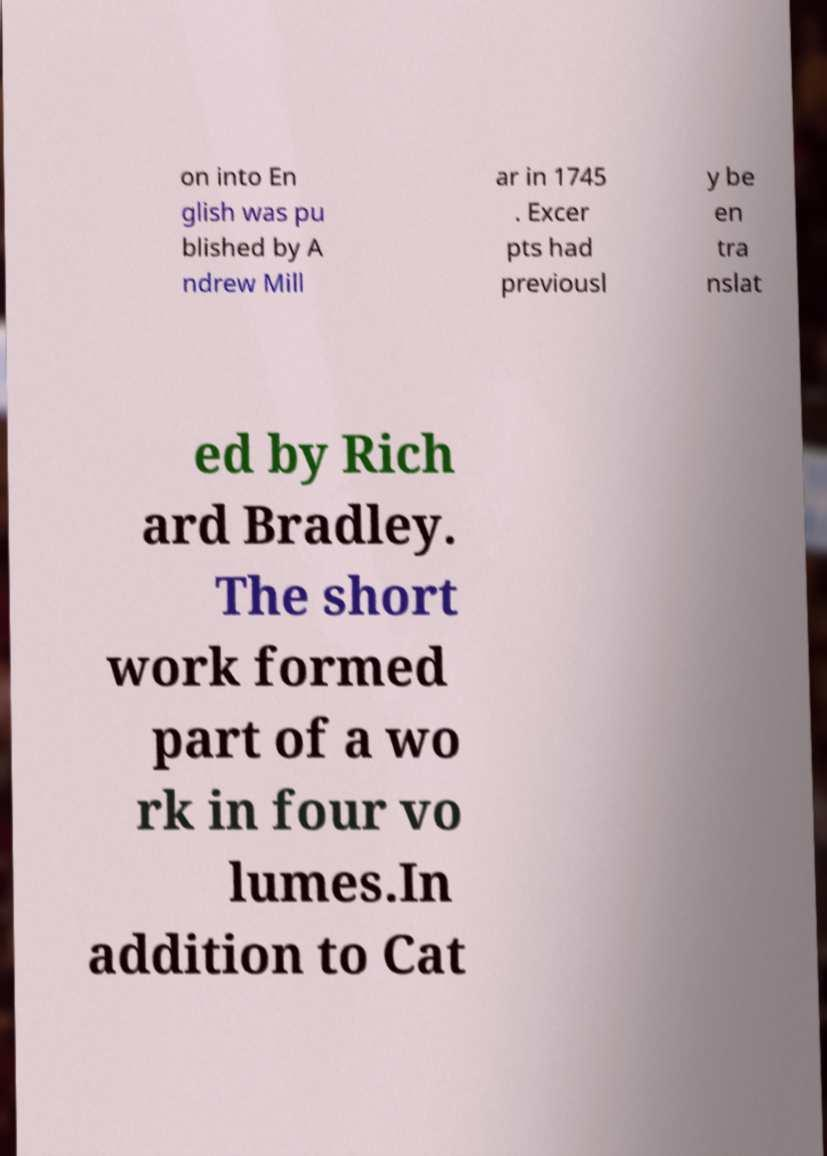What messages or text are displayed in this image? I need them in a readable, typed format. on into En glish was pu blished by A ndrew Mill ar in 1745 . Excer pts had previousl y be en tra nslat ed by Rich ard Bradley. The short work formed part of a wo rk in four vo lumes.In addition to Cat 